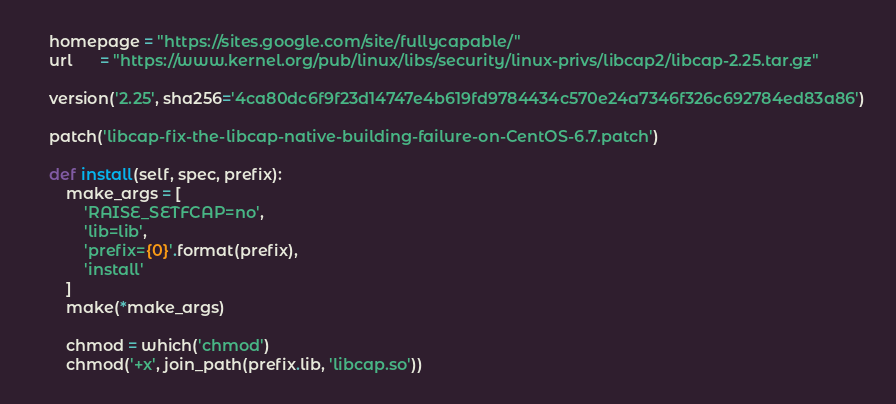Convert code to text. <code><loc_0><loc_0><loc_500><loc_500><_Python_>
    homepage = "https://sites.google.com/site/fullycapable/"
    url      = "https://www.kernel.org/pub/linux/libs/security/linux-privs/libcap2/libcap-2.25.tar.gz"

    version('2.25', sha256='4ca80dc6f9f23d14747e4b619fd9784434c570e24a7346f326c692784ed83a86')

    patch('libcap-fix-the-libcap-native-building-failure-on-CentOS-6.7.patch')

    def install(self, spec, prefix):
        make_args = [
            'RAISE_SETFCAP=no',
            'lib=lib',
            'prefix={0}'.format(prefix),
            'install'
        ]
        make(*make_args)

        chmod = which('chmod')
        chmod('+x', join_path(prefix.lib, 'libcap.so'))
</code> 